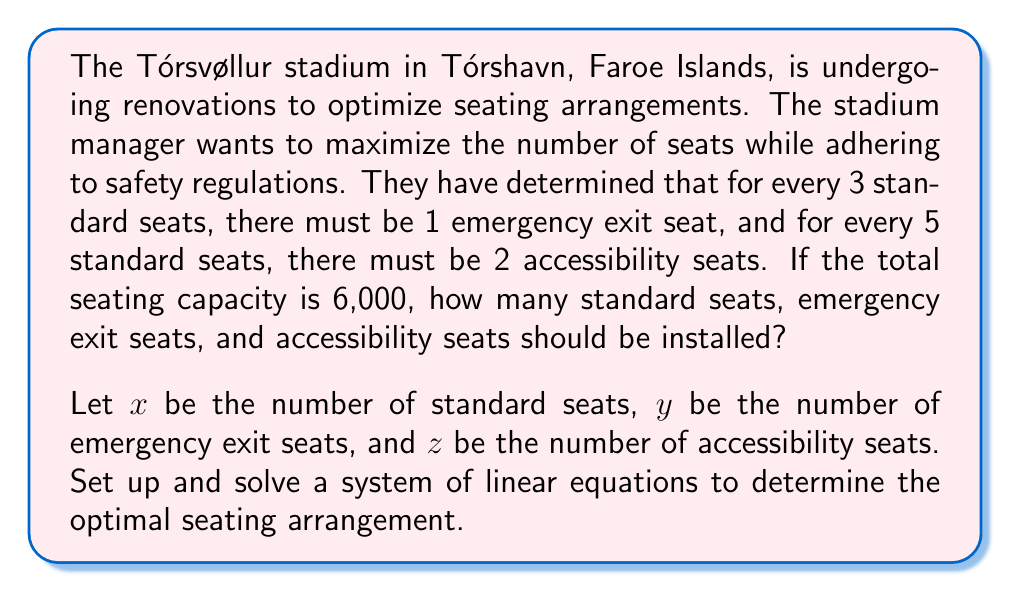Teach me how to tackle this problem. Let's approach this step-by-step:

1) First, we need to set up our system of linear equations based on the given information:

   a) Total seats equation: 
      $$ x + y + z = 6000 $$

   b) Emergency exit seats ratio:
      $$ y = \frac{1}{3}x $$

   c) Accessibility seats ratio:
      $$ z = \frac{2}{5}x $$

2) Now we have a system of three equations with three unknowns:

   $$ \begin{cases}
   x + y + z = 6000 \\
   y = \frac{1}{3}x \\
   z = \frac{2}{5}x
   \end{cases} $$

3) Substitute the expressions for $y$ and $z$ into the first equation:

   $$ x + \frac{1}{3}x + \frac{2}{5}x = 6000 $$

4) Simplify by finding a common denominator:

   $$ \frac{15x}{15} + \frac{5x}{15} + \frac{6x}{15} = 6000 $$
   $$ \frac{26x}{15} = 6000 $$

5) Solve for $x$:

   $$ x = 6000 \cdot \frac{15}{26} = 3461.54 $$

   Since we can't have fractional seats, we round down to 3461 standard seats.

6) Now calculate $y$ and $z$:

   $$ y = \frac{1}{3} \cdot 3461 = 1153.67 \approx 1153 \text{ emergency exit seats} $$
   $$ z = \frac{2}{5} \cdot 3461 = 1384.4 \approx 1384 \text{ accessibility seats} $$

7) Check the total:
   $$ 3461 + 1153 + 1384 = 5998 $$

   This is as close as we can get to 6000 while maintaining the required ratios and using whole numbers.
Answer: The optimal seating arrangement for the Tórsvøllur stadium is:
$$ \begin{aligned}
\text{Standard seats} &= 3461 \\
\text{Emergency exit seats} &= 1153 \\
\text{Accessibility seats} &= 1384
\end{aligned} $$ 